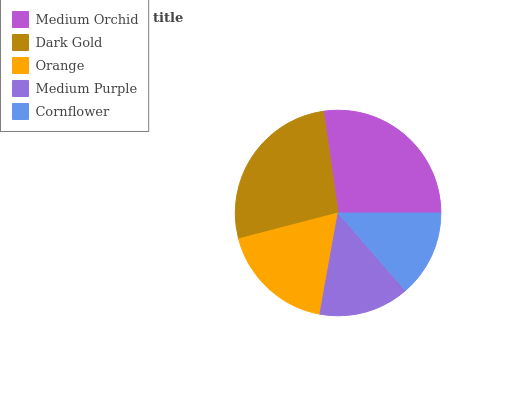Is Cornflower the minimum?
Answer yes or no. Yes. Is Medium Orchid the maximum?
Answer yes or no. Yes. Is Dark Gold the minimum?
Answer yes or no. No. Is Dark Gold the maximum?
Answer yes or no. No. Is Medium Orchid greater than Dark Gold?
Answer yes or no. Yes. Is Dark Gold less than Medium Orchid?
Answer yes or no. Yes. Is Dark Gold greater than Medium Orchid?
Answer yes or no. No. Is Medium Orchid less than Dark Gold?
Answer yes or no. No. Is Orange the high median?
Answer yes or no. Yes. Is Orange the low median?
Answer yes or no. Yes. Is Cornflower the high median?
Answer yes or no. No. Is Medium Orchid the low median?
Answer yes or no. No. 